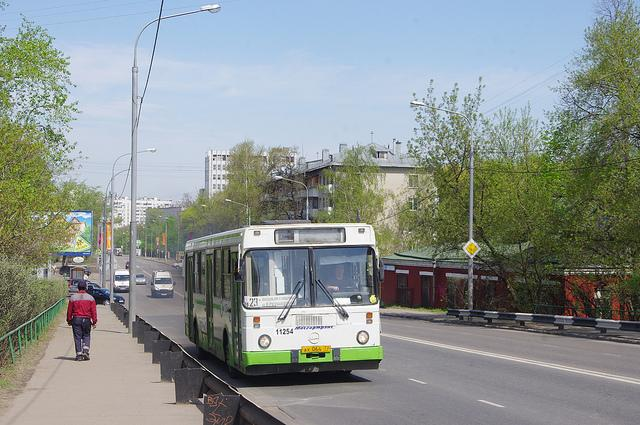Which car is in the greatest danger? black car 